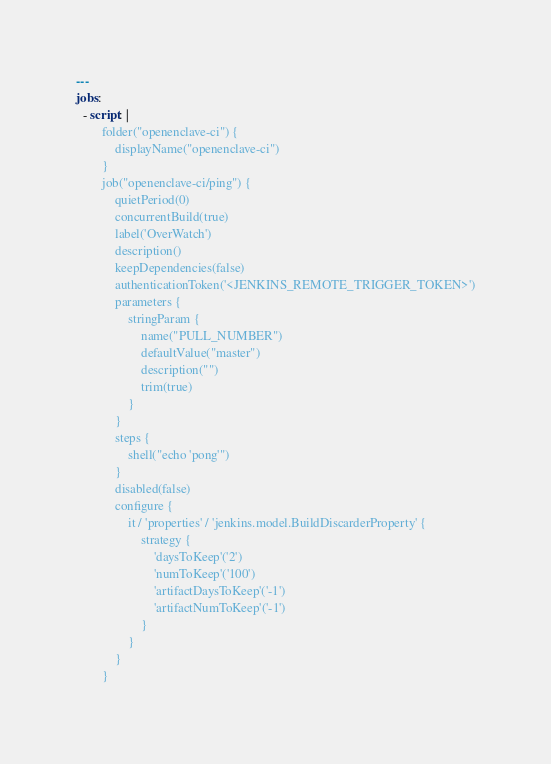Convert code to text. <code><loc_0><loc_0><loc_500><loc_500><_YAML_>---
jobs:
  - script: |
        folder("openenclave-ci") {
            displayName("openenclave-ci")
        }
        job("openenclave-ci/ping") {
            quietPeriod(0)
            concurrentBuild(true)
            label('OverWatch')
            description()
            keepDependencies(false)
            authenticationToken('<JENKINS_REMOTE_TRIGGER_TOKEN>')
            parameters {
                stringParam {
                    name("PULL_NUMBER")
                    defaultValue("master")
                    description("")
                    trim(true)
                }
            }
            steps {
                shell("echo 'pong'")
            }
            disabled(false)
            configure {
                it / 'properties' / 'jenkins.model.BuildDiscarderProperty' {
                    strategy {
                        'daysToKeep'('2')
                        'numToKeep'('100')
                        'artifactDaysToKeep'('-1')
                        'artifactNumToKeep'('-1')
                    }
                }
            }
        }        
</code> 